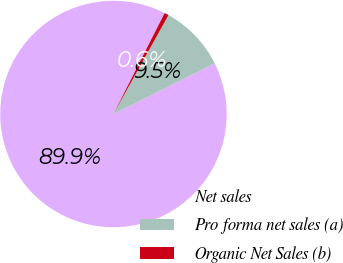Convert chart to OTSL. <chart><loc_0><loc_0><loc_500><loc_500><pie_chart><fcel>Net sales<fcel>Pro forma net sales (a)<fcel>Organic Net Sales (b)<nl><fcel>89.86%<fcel>9.53%<fcel>0.61%<nl></chart> 